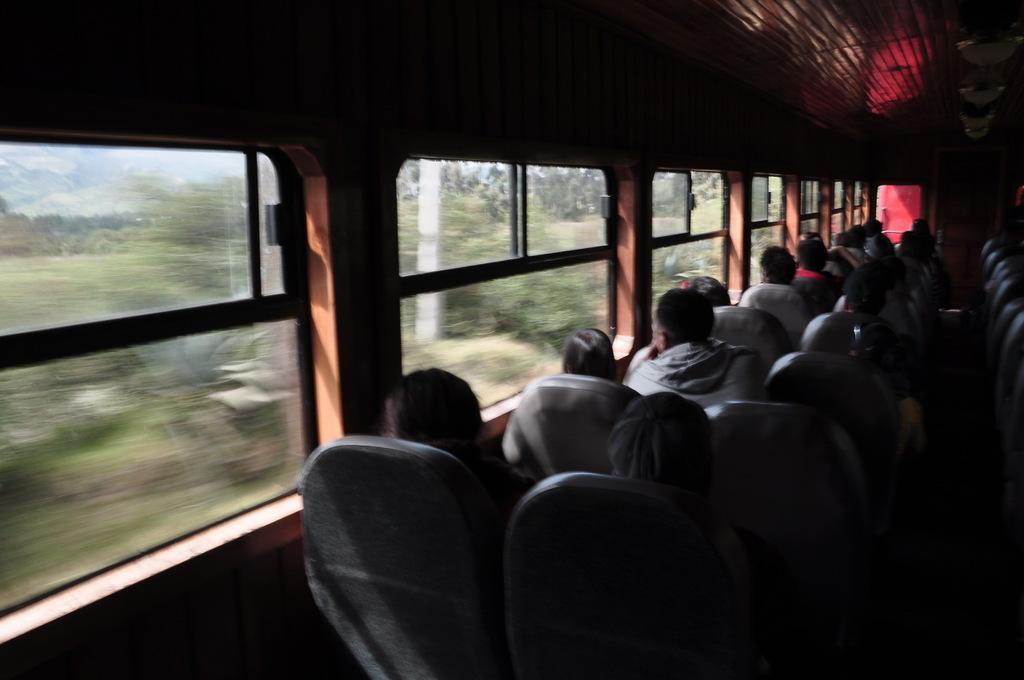What is the main subject of the image? The main subject of the image is a train. What can be seen inside the train? There are many people sitting in the train. What feature is present on the left side of the train? There are windows on the left side of the train. Where is the luggage stored in the train? There is a luggage rack at the top of the train. How many seats are visible in the front of the train? There are many seats in the front of the train. What type of cord is being used to tie the berries together in the image? There are no berries or cords present in the image; it features a train with people sitting inside. 